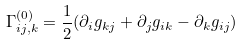Convert formula to latex. <formula><loc_0><loc_0><loc_500><loc_500>\Gamma ^ { ( 0 ) } _ { i j , k } = \frac { 1 } { 2 } ( \partial _ { i } g _ { k j } + \partial _ { j } g _ { i k } - \partial _ { k } g _ { i j } )</formula> 